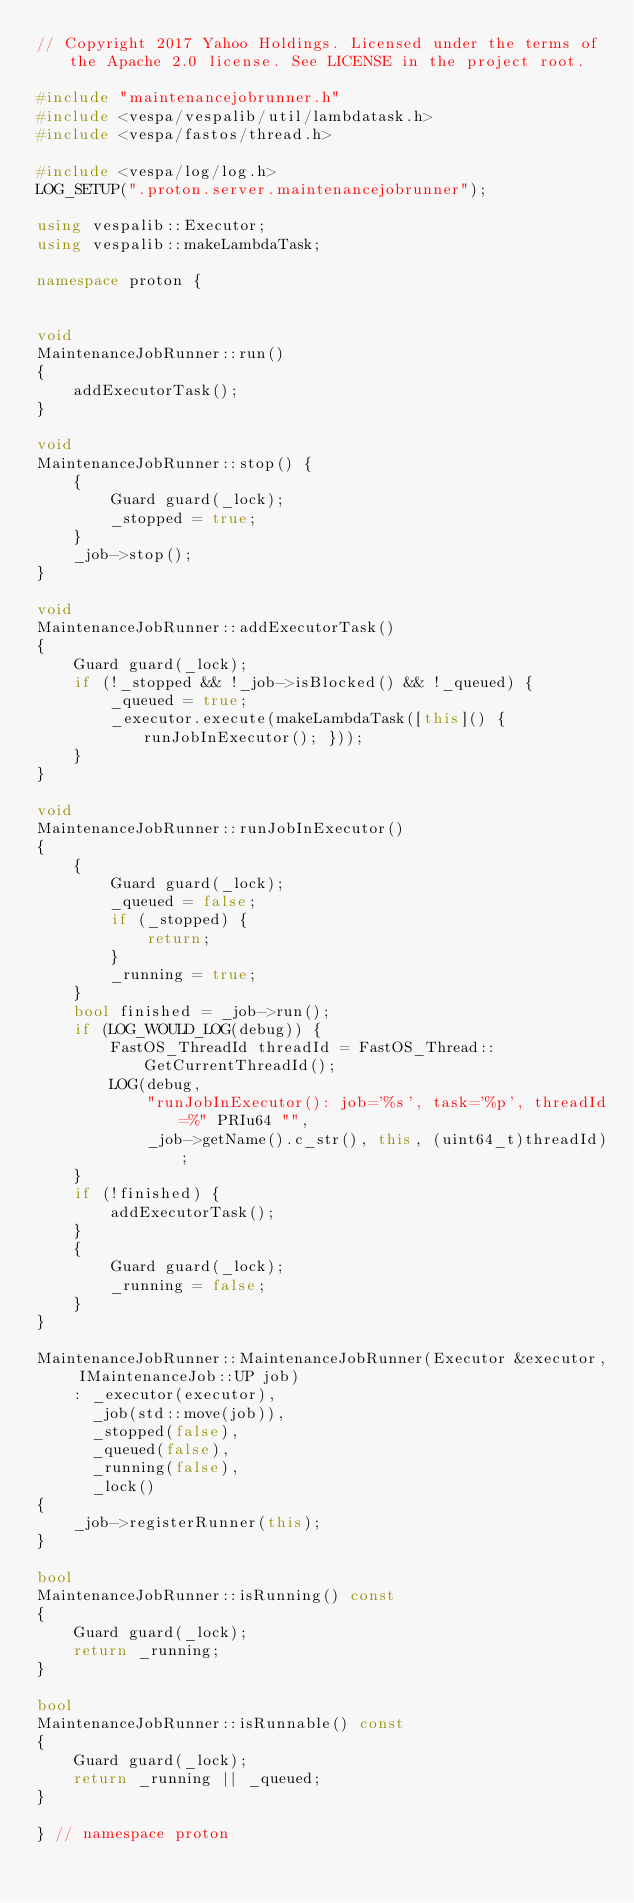<code> <loc_0><loc_0><loc_500><loc_500><_C++_>// Copyright 2017 Yahoo Holdings. Licensed under the terms of the Apache 2.0 license. See LICENSE in the project root.

#include "maintenancejobrunner.h"
#include <vespa/vespalib/util/lambdatask.h>
#include <vespa/fastos/thread.h>

#include <vespa/log/log.h>
LOG_SETUP(".proton.server.maintenancejobrunner");

using vespalib::Executor;
using vespalib::makeLambdaTask;

namespace proton {


void
MaintenanceJobRunner::run()
{
    addExecutorTask();
}

void
MaintenanceJobRunner::stop() {
    {
        Guard guard(_lock);
        _stopped = true;
    }
    _job->stop();
}

void
MaintenanceJobRunner::addExecutorTask()
{
    Guard guard(_lock);
    if (!_stopped && !_job->isBlocked() && !_queued) {
        _queued = true;
        _executor.execute(makeLambdaTask([this]() { runJobInExecutor(); }));
    }
}

void
MaintenanceJobRunner::runJobInExecutor()
{
    {
        Guard guard(_lock);
        _queued = false;
        if (_stopped) {
            return;
        }
        _running = true;
    }
    bool finished = _job->run();
    if (LOG_WOULD_LOG(debug)) {
        FastOS_ThreadId threadId = FastOS_Thread::GetCurrentThreadId();
        LOG(debug,
            "runJobInExecutor(): job='%s', task='%p', threadId=%" PRIu64 "",
            _job->getName().c_str(), this, (uint64_t)threadId);
    }
    if (!finished) {
        addExecutorTask();
    }
    {
        Guard guard(_lock);
        _running = false;
    }
}

MaintenanceJobRunner::MaintenanceJobRunner(Executor &executor, IMaintenanceJob::UP job)
    : _executor(executor),
      _job(std::move(job)),
      _stopped(false),
      _queued(false),
      _running(false),
      _lock()
{
    _job->registerRunner(this);
}

bool
MaintenanceJobRunner::isRunning() const
{
    Guard guard(_lock);
    return _running;
}

bool
MaintenanceJobRunner::isRunnable() const
{
    Guard guard(_lock);
    return _running || _queued;
}

} // namespace proton
</code> 